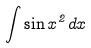Convert formula to latex. <formula><loc_0><loc_0><loc_500><loc_500>\int \sin x ^ { 2 } d x</formula> 